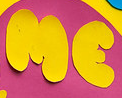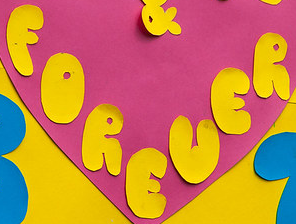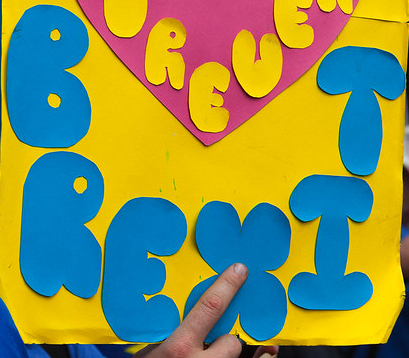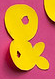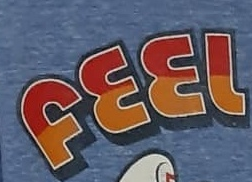Read the text from these images in sequence, separated by a semicolon. ME; FOREUER; BREXIT; &; FEEL 